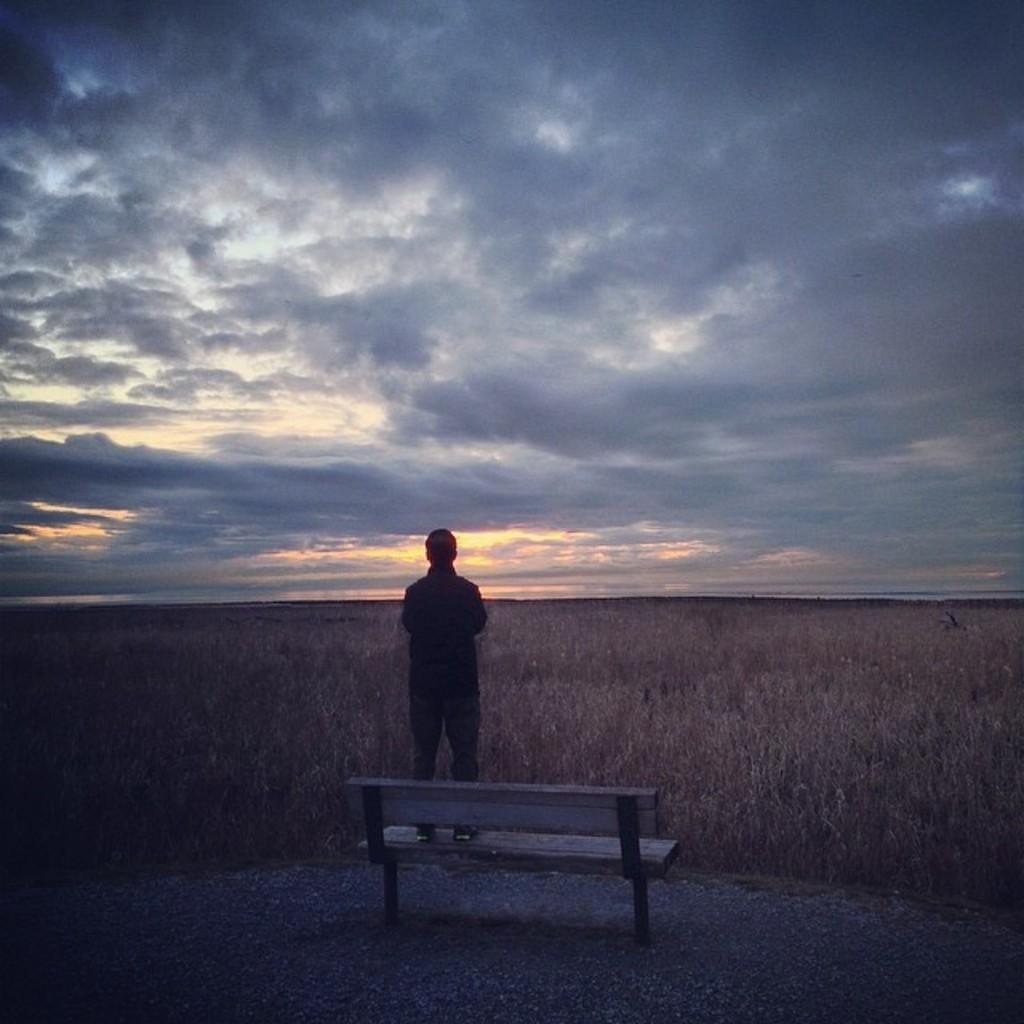Could you give a brief overview of what you see in this image? In this picture we can see a person is standing on a bench, in the background there are some plants, we can see the sky and clouds at the top of the picture. 